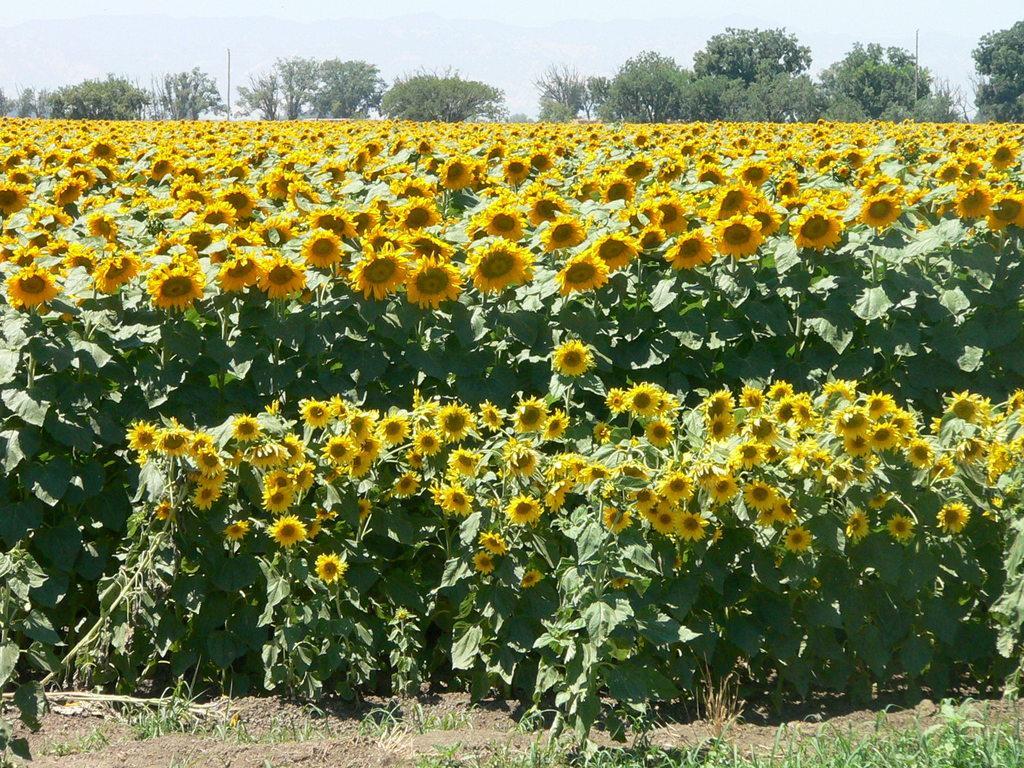In one or two sentences, can you explain what this image depicts? In this image, there is an outside view. There are plants contains some flowers. There are some trees and sky at the top of the image. 